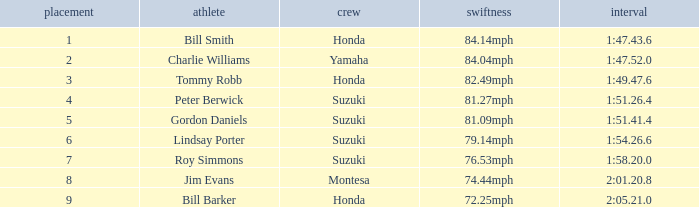Which rider had a time of 1:54.26.6? Lindsay Porter. 